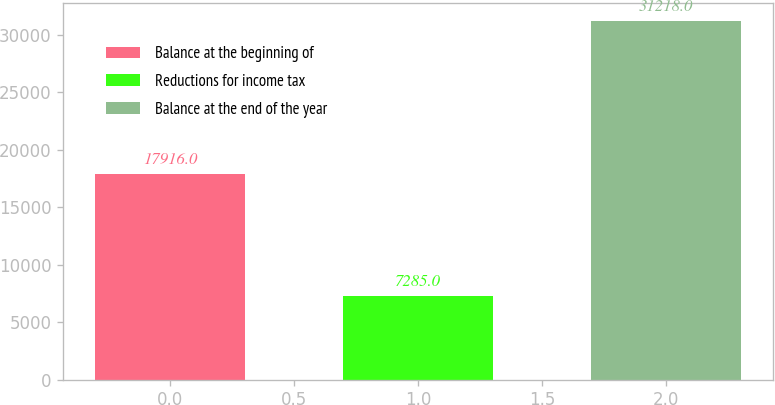<chart> <loc_0><loc_0><loc_500><loc_500><bar_chart><fcel>Balance at the beginning of<fcel>Reductions for income tax<fcel>Balance at the end of the year<nl><fcel>17916<fcel>7285<fcel>31218<nl></chart> 